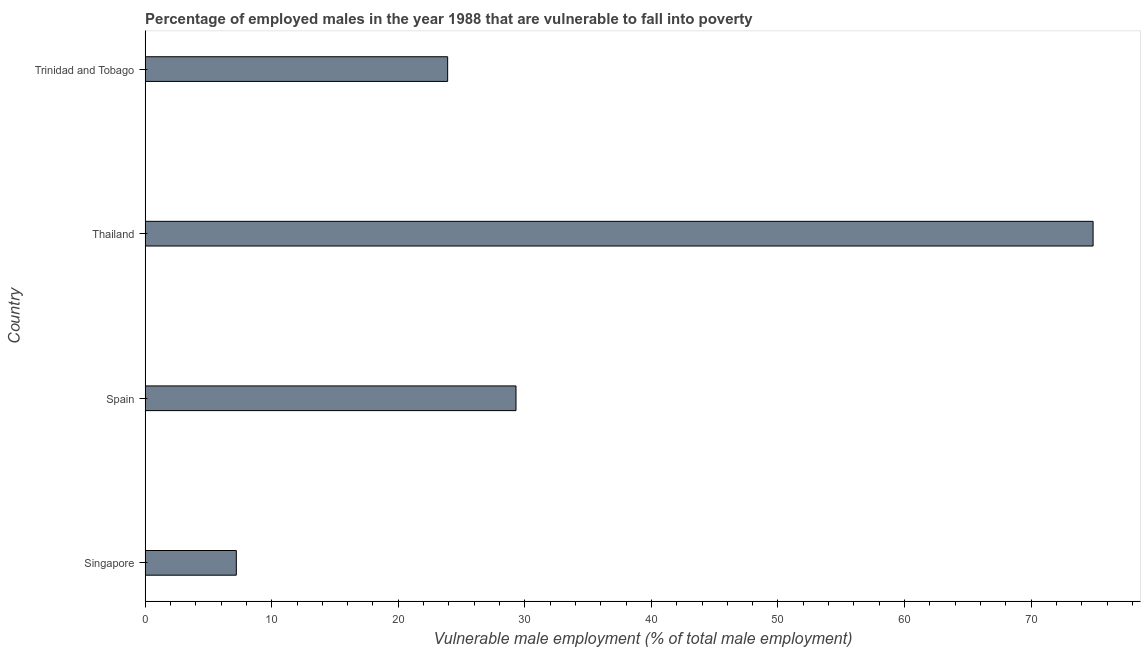What is the title of the graph?
Keep it short and to the point. Percentage of employed males in the year 1988 that are vulnerable to fall into poverty. What is the label or title of the X-axis?
Your answer should be very brief. Vulnerable male employment (% of total male employment). What is the label or title of the Y-axis?
Your answer should be very brief. Country. What is the percentage of employed males who are vulnerable to fall into poverty in Spain?
Give a very brief answer. 29.3. Across all countries, what is the maximum percentage of employed males who are vulnerable to fall into poverty?
Keep it short and to the point. 74.9. Across all countries, what is the minimum percentage of employed males who are vulnerable to fall into poverty?
Keep it short and to the point. 7.2. In which country was the percentage of employed males who are vulnerable to fall into poverty maximum?
Make the answer very short. Thailand. In which country was the percentage of employed males who are vulnerable to fall into poverty minimum?
Provide a short and direct response. Singapore. What is the sum of the percentage of employed males who are vulnerable to fall into poverty?
Keep it short and to the point. 135.3. What is the average percentage of employed males who are vulnerable to fall into poverty per country?
Offer a terse response. 33.83. What is the median percentage of employed males who are vulnerable to fall into poverty?
Give a very brief answer. 26.6. In how many countries, is the percentage of employed males who are vulnerable to fall into poverty greater than 52 %?
Ensure brevity in your answer.  1. What is the ratio of the percentage of employed males who are vulnerable to fall into poverty in Thailand to that in Trinidad and Tobago?
Offer a terse response. 3.13. Is the difference between the percentage of employed males who are vulnerable to fall into poverty in Spain and Thailand greater than the difference between any two countries?
Provide a short and direct response. No. What is the difference between the highest and the second highest percentage of employed males who are vulnerable to fall into poverty?
Make the answer very short. 45.6. What is the difference between the highest and the lowest percentage of employed males who are vulnerable to fall into poverty?
Your response must be concise. 67.7. How many bars are there?
Offer a terse response. 4. How many countries are there in the graph?
Keep it short and to the point. 4. Are the values on the major ticks of X-axis written in scientific E-notation?
Give a very brief answer. No. What is the Vulnerable male employment (% of total male employment) in Singapore?
Your answer should be compact. 7.2. What is the Vulnerable male employment (% of total male employment) of Spain?
Your answer should be very brief. 29.3. What is the Vulnerable male employment (% of total male employment) in Thailand?
Keep it short and to the point. 74.9. What is the Vulnerable male employment (% of total male employment) in Trinidad and Tobago?
Offer a terse response. 23.9. What is the difference between the Vulnerable male employment (% of total male employment) in Singapore and Spain?
Offer a very short reply. -22.1. What is the difference between the Vulnerable male employment (% of total male employment) in Singapore and Thailand?
Keep it short and to the point. -67.7. What is the difference between the Vulnerable male employment (% of total male employment) in Singapore and Trinidad and Tobago?
Your response must be concise. -16.7. What is the difference between the Vulnerable male employment (% of total male employment) in Spain and Thailand?
Offer a terse response. -45.6. What is the difference between the Vulnerable male employment (% of total male employment) in Spain and Trinidad and Tobago?
Give a very brief answer. 5.4. What is the ratio of the Vulnerable male employment (% of total male employment) in Singapore to that in Spain?
Make the answer very short. 0.25. What is the ratio of the Vulnerable male employment (% of total male employment) in Singapore to that in Thailand?
Offer a terse response. 0.1. What is the ratio of the Vulnerable male employment (% of total male employment) in Singapore to that in Trinidad and Tobago?
Provide a succinct answer. 0.3. What is the ratio of the Vulnerable male employment (% of total male employment) in Spain to that in Thailand?
Keep it short and to the point. 0.39. What is the ratio of the Vulnerable male employment (% of total male employment) in Spain to that in Trinidad and Tobago?
Offer a terse response. 1.23. What is the ratio of the Vulnerable male employment (% of total male employment) in Thailand to that in Trinidad and Tobago?
Offer a terse response. 3.13. 